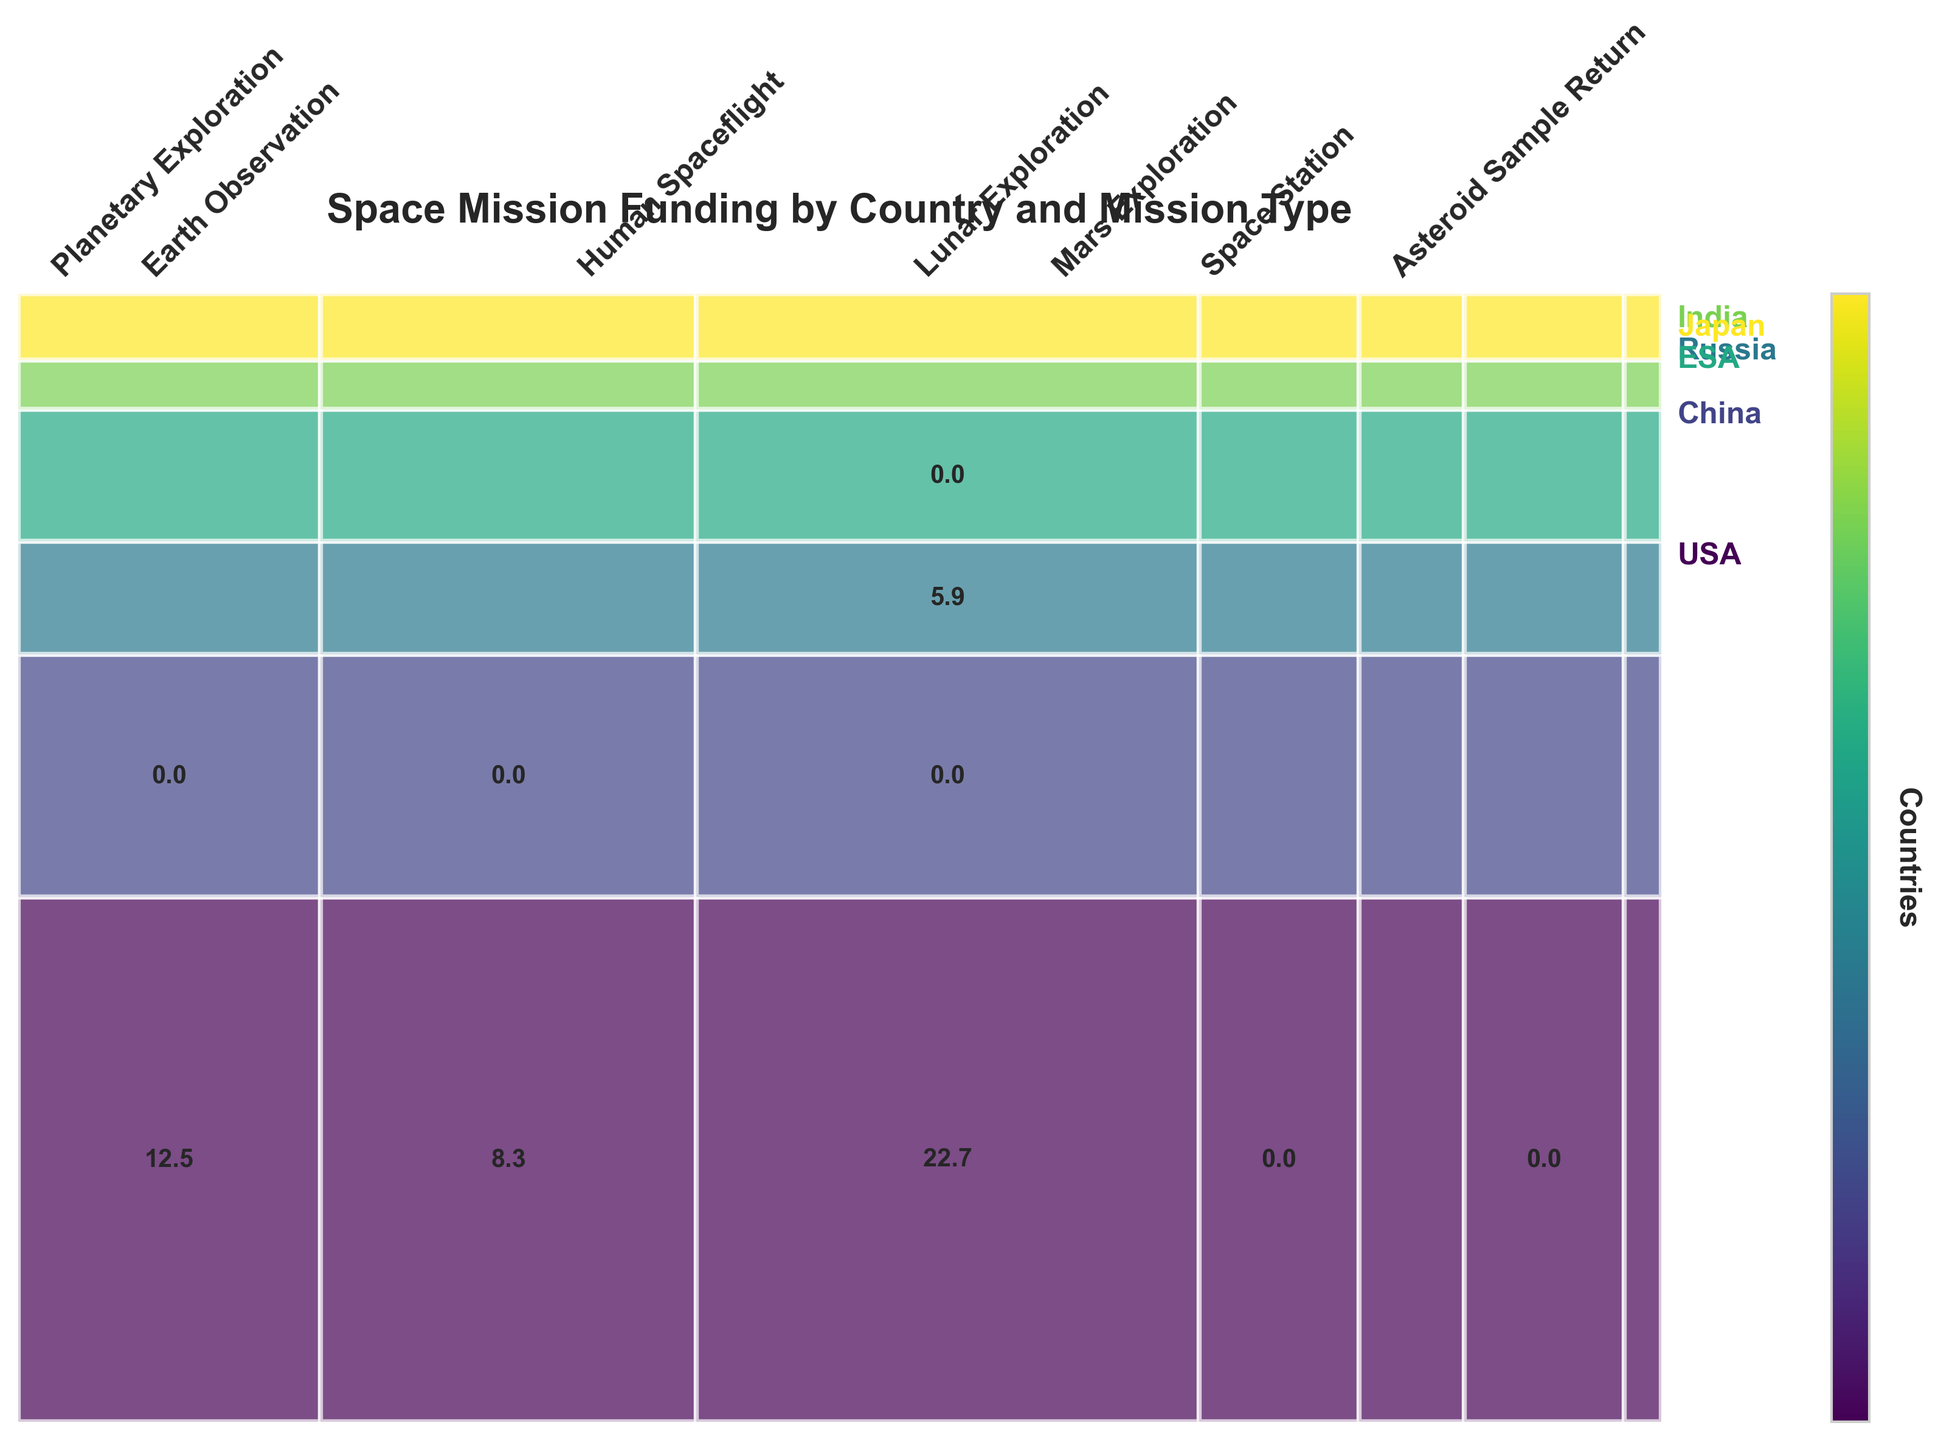What type of missions does USA fund the most? By examining the heights of the rectangles which represent the funding for each mission type within the USA section (identified by a unique color), the Human Spaceflight rectangle has the largest height.
Answer: Human Spaceflight Which mission type has the least funding from India? For India, the widths of the bars representing Mars Exploration and Lunar Exploration should be compared. The Mars Exploration rectangle width is narrower.
Answer: Mars Exploration What is the total funding for Lunar Exploration missions across all countries? Sum the funding for Lunar Exploration missions across all represented countries by examining each relevant rectangle's area and corresponding label: China (6.8), India (2.3).
Answer: 9.1 Is human spaceflight funded more by USA or Russia? Compare the height of the Human Spaceflight segments for USA and Russia. The USA segment has a greater height.
Answer: USA What is the proportion of funding for Earth Observation missions by Russia relative to the total funding for Earth Observation missions? Calculate the width of Russia's Earth Observation bar as a fraction of the total Earth Observation part of the mosaic plot. Russia's rectangle covers less area when compared to those from other countries like USA and ESA.
Answer: Low Which country has the broadest range of mission types funded? Assess each country's sections to see the number of different colored rectangles that represent distinct mission types. USA covers Planetary Exploration, Earth Observation, and Human Spaceflight (3 types), which is the broadest range.,
Answer: USA By how much does the funding for ESA's Earth Observation surpass that of Japan's? Compare the sizes (widths) of the rectangles for Earth Observation for ESA and Japan. The difference is labeled amounts: ESA (6.2) minus Japan (3.4).
Answer: 2.8 billion USD Which mission type has the highest combined funding? Summing each mission type's total across all countries by calculating the total horizontal width of each mission type's section reveals Human Spaceflight from the USA and Russia as a directly noticeable dominant funding type.
Answer: Human Spaceflight 